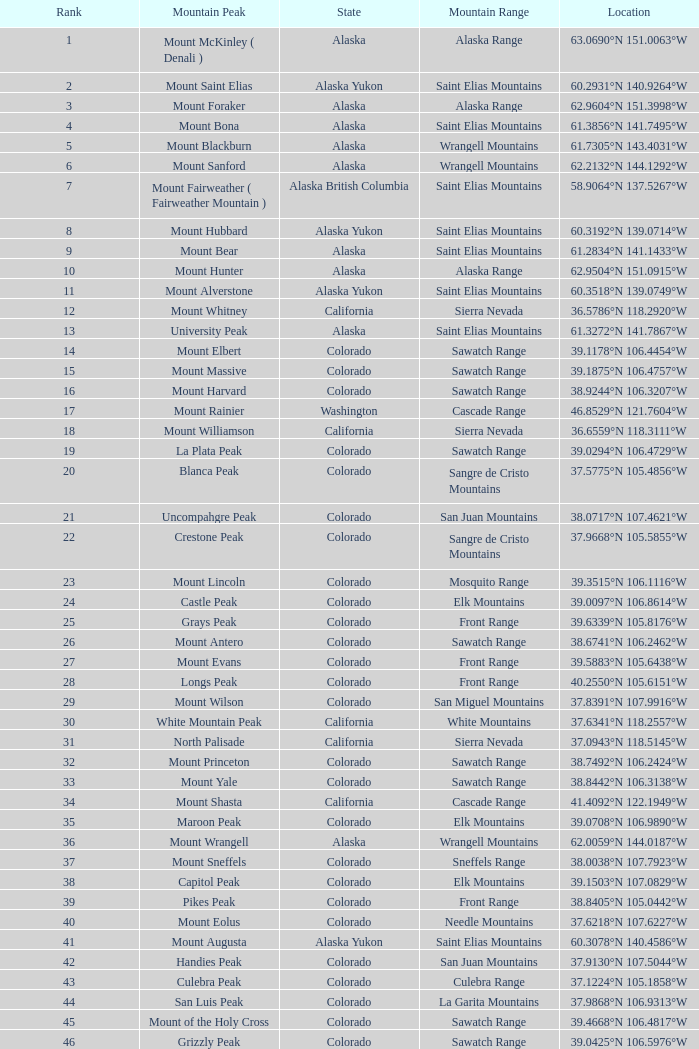5775°n 10 Blanca Peak. 